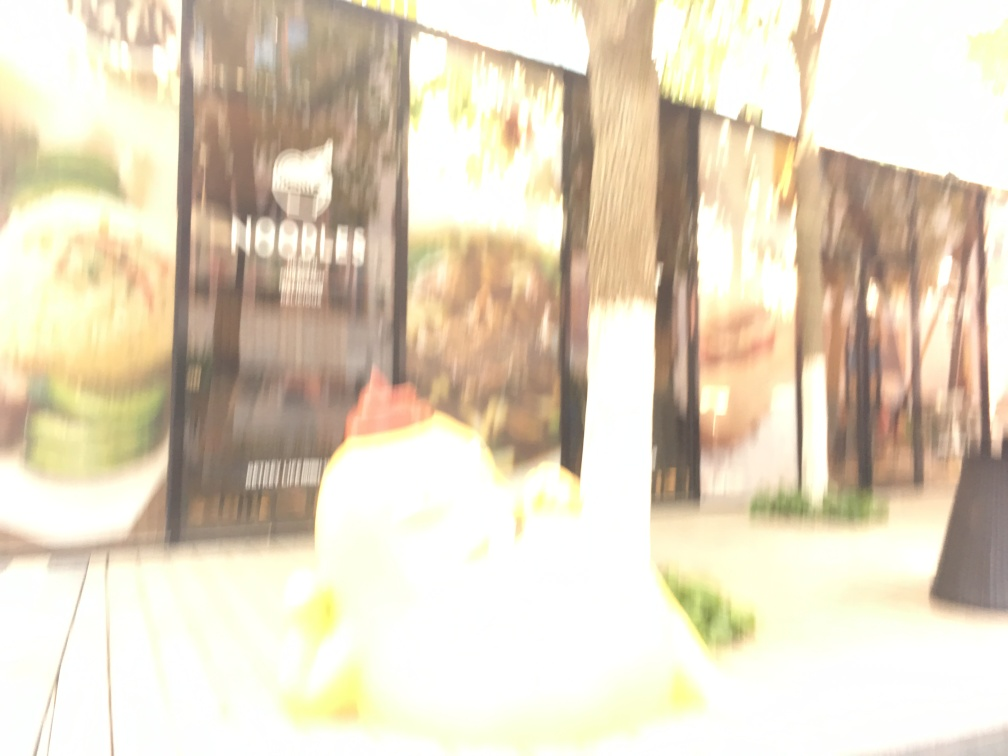Can you suggest how to prevent this kind of overexposure and blurriness in future photographs? To prevent overexposure, ensure that your camera settings are adjusted according to the lighting conditions; use a lower ISO, faster shutter speed, or a smaller aperture. To avoid blurriness, use a tripod or stabilize your camera to prevent movement, and make sure the focus is set correctly for your subject. Could weather or the environment play a role in image quality like this? Absolutely, environmental conditions such as bright sunlight, or fog can contribute to overexposure and a hazy image. In such conditions, using lens hoods and filters can help manage the light entering the lens and protect against lens flare and atmospheric effects that could degrade image sharpness. 